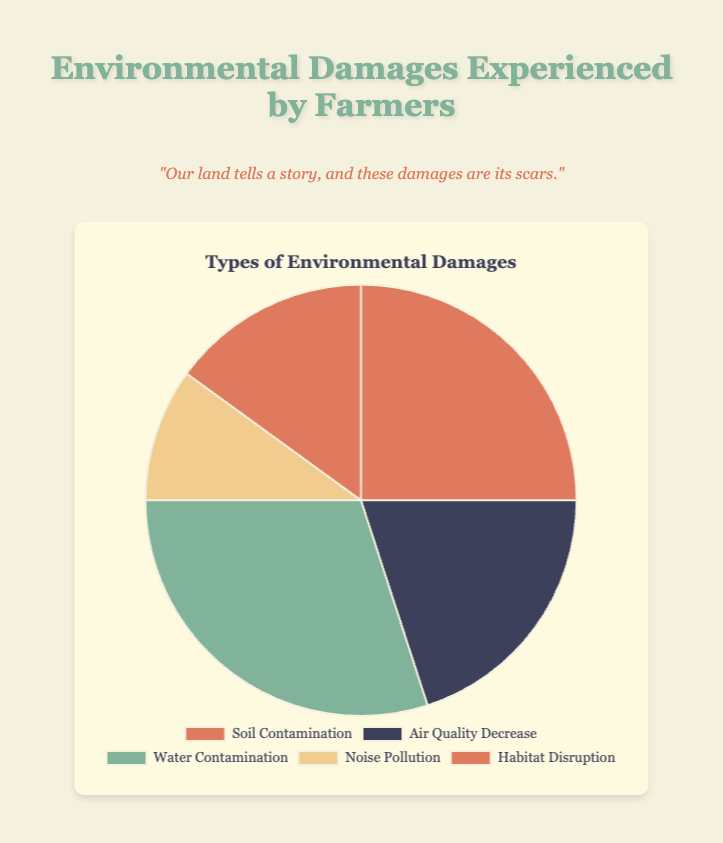What is the most common type of environmental damage experienced by farmers according to the pie chart? The pie chart shows different types of environmental damages with their respective percentages. The segment with the highest percentage represents the most common type of damage. In this case, "Water Contamination" has the highest percentage at 30%.
Answer: Water Contamination Which type of environmental damage has the smallest share in the pie chart? The smallest segment in the pie chart corresponds to "Noise Pollution," which has the lowest percentage (10%).
Answer: Noise Pollution What is the combined percentage of Soil Contamination and Habitat Disruption? Add the percentages of Soil Contamination (25%) and Habitat Disruption (15%). The combined percentage is 25% + 15% = 40%.
Answer: 40% Is Air Quality Decrease more prevalent than Habitat Disruption according to the chart? Compare the percentages of Air Quality Decrease (20%) and Habitat Disruption (15%). Since 20% is greater than 15%, Air Quality Decrease is more prevalent.
Answer: Yes What is the difference in percentage between Water Contamination and Noise Pollution? Subtract the percentage of Noise Pollution (10%) from the percentage of Water Contamination (30%). The difference is 30% - 10% = 20%.
Answer: 20% If the percentages of Soil Contamination and Air Quality Decrease were combined, would their total be more or less than the percentage of Water Contamination? Add the percentages of Soil Contamination (25%) and Air Quality Decrease (20%) to find their combined total: 25% + 20% = 45%. Compare this to the percentage of Water Contamination (30%). Since 45% is greater than 30%, the combined total is more.
Answer: More What percentage of environmental damages are not related to water, by summing up all other categories? Add up the percentages of all types of damages except Water Contamination: Soil Contamination (25%) + Air Quality Decrease (20%) + Noise Pollution (10%) + Habitat Disruption (15%). The total is 25% + 20% + 10% + 15% = 70%.
Answer: 70% Which environmental damage is represented by a green color in the pie chart? The green color segment in the pie chart depicts "Air Quality Decrease."
Answer: Air Quality Decrease How many types of environmental damages have a percentage equal to or greater than 15%? Count the segments with percentages equal to or greater than 15%. These are Soil Contamination (25%), Air Quality Decrease (20%), Water Contamination (30%), and Habitat Disruption (15%), making a total of 4 types.
Answer: 4 